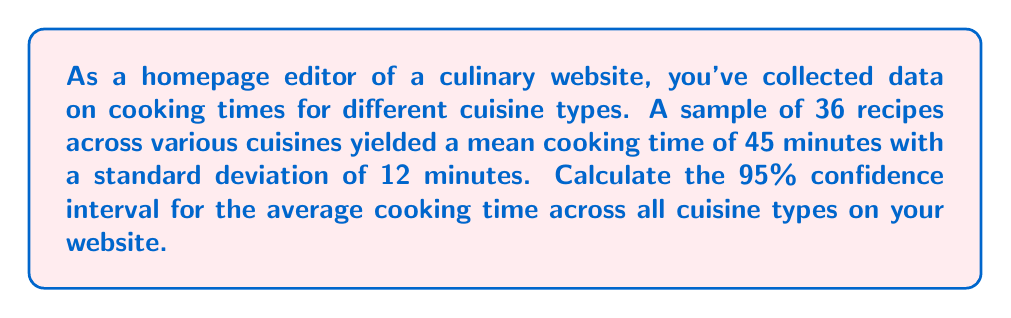Show me your answer to this math problem. To calculate the confidence interval, we'll follow these steps:

1. Identify the given information:
   - Sample size (n) = 36
   - Sample mean ($\bar{x}$) = 45 minutes
   - Sample standard deviation (s) = 12 minutes
   - Confidence level = 95%

2. Determine the critical value:
   For a 95% confidence level with df = 35 (n - 1), the t-critical value is approximately 2.030 (from t-distribution table).

3. Calculate the standard error of the mean:
   $SE = \frac{s}{\sqrt{n}} = \frac{12}{\sqrt{36}} = \frac{12}{6} = 2$

4. Calculate the margin of error:
   $ME = t_{critical} \times SE = 2.030 \times 2 = 4.06$

5. Compute the confidence interval:
   Lower bound: $\bar{x} - ME = 45 - 4.06 = 40.94$
   Upper bound: $\bar{x} + ME = 45 + 4.06 = 49.06$

Therefore, the 95% confidence interval for the average cooking time across all cuisine types is (40.94, 49.06) minutes.
Answer: (40.94, 49.06) minutes 